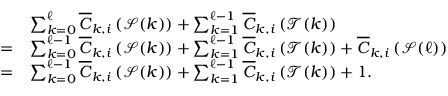<formula> <loc_0><loc_0><loc_500><loc_500>\begin{array} { r l } & { \sum _ { k = 0 } ^ { \ell } \overline { C } _ { k , i } \left ( \mathcal { S } ( k ) \right ) + \sum _ { k = 1 } ^ { \ell - 1 } \overline { C } _ { k , i } \left ( \mathcal { T } ( k ) \right ) } \\ { = } & { \sum _ { k = 0 } ^ { \ell - 1 } \overline { C } _ { k , i } \left ( \mathcal { S } ( k ) \right ) + \sum _ { k = 1 } ^ { \ell - 1 } \overline { C } _ { k , i } \left ( \mathcal { T } ( k ) \right ) + \overline { C } _ { k , i } \left ( \mathcal { S } ( \ell ) \right ) } \\ { = } & { \sum _ { k = 0 } ^ { \ell - 1 } \overline { C } _ { k , i } \left ( \mathcal { S } ( k ) \right ) + \sum _ { k = 1 } ^ { \ell - 1 } \overline { C } _ { k , i } \left ( \mathcal { T } ( k ) \right ) + 1 . } \end{array}</formula> 